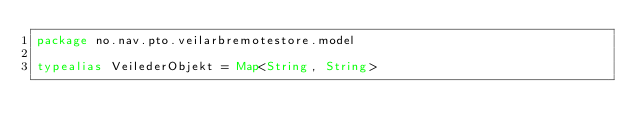Convert code to text. <code><loc_0><loc_0><loc_500><loc_500><_Kotlin_>package no.nav.pto.veilarbremotestore.model

typealias VeilederObjekt = Map<String, String>
</code> 